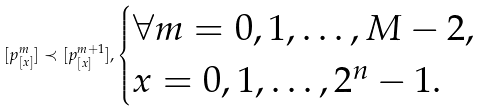Convert formula to latex. <formula><loc_0><loc_0><loc_500><loc_500>[ p ^ { m } _ { [ x ] } ] \prec [ p ^ { m + 1 } _ { [ x ] } ] , \begin{cases} \forall m = 0 , 1 , \dots , M - 2 , \\ x = 0 , 1 , \dots , 2 ^ { n } - 1 . \end{cases}</formula> 